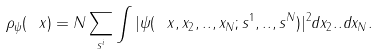Convert formula to latex. <formula><loc_0><loc_0><loc_500><loc_500>\rho _ { \psi } ( \ x ) = N \sum _ { s ^ { i } } \int | \psi ( \ x , x _ { 2 } , . . , x _ { N } ; s ^ { 1 } , . . , s ^ { N } ) | ^ { 2 } d x _ { 2 } . . d x _ { N } .</formula> 